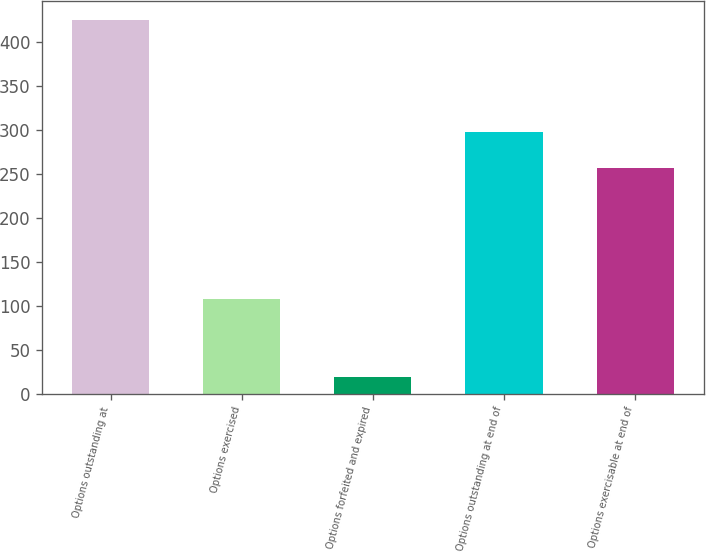<chart> <loc_0><loc_0><loc_500><loc_500><bar_chart><fcel>Options outstanding at<fcel>Options exercised<fcel>Options forfeited and expired<fcel>Options outstanding at end of<fcel>Options exercisable at end of<nl><fcel>425<fcel>108<fcel>19<fcel>298<fcel>257<nl></chart> 